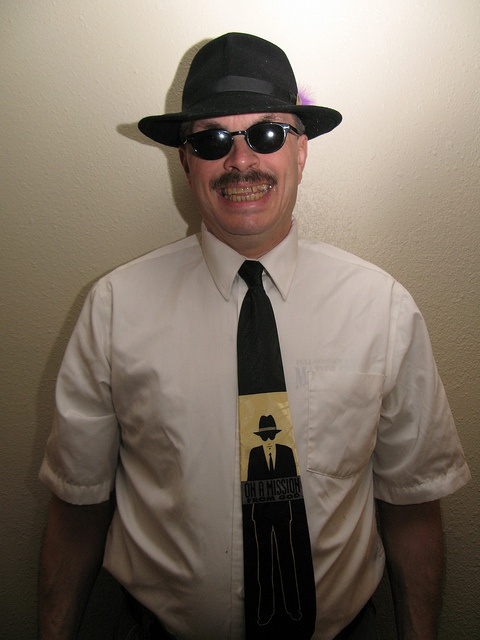Describe the objects in this image and their specific colors. I can see people in darkgray, black, and gray tones and tie in darkgray, black, olive, and gray tones in this image. 